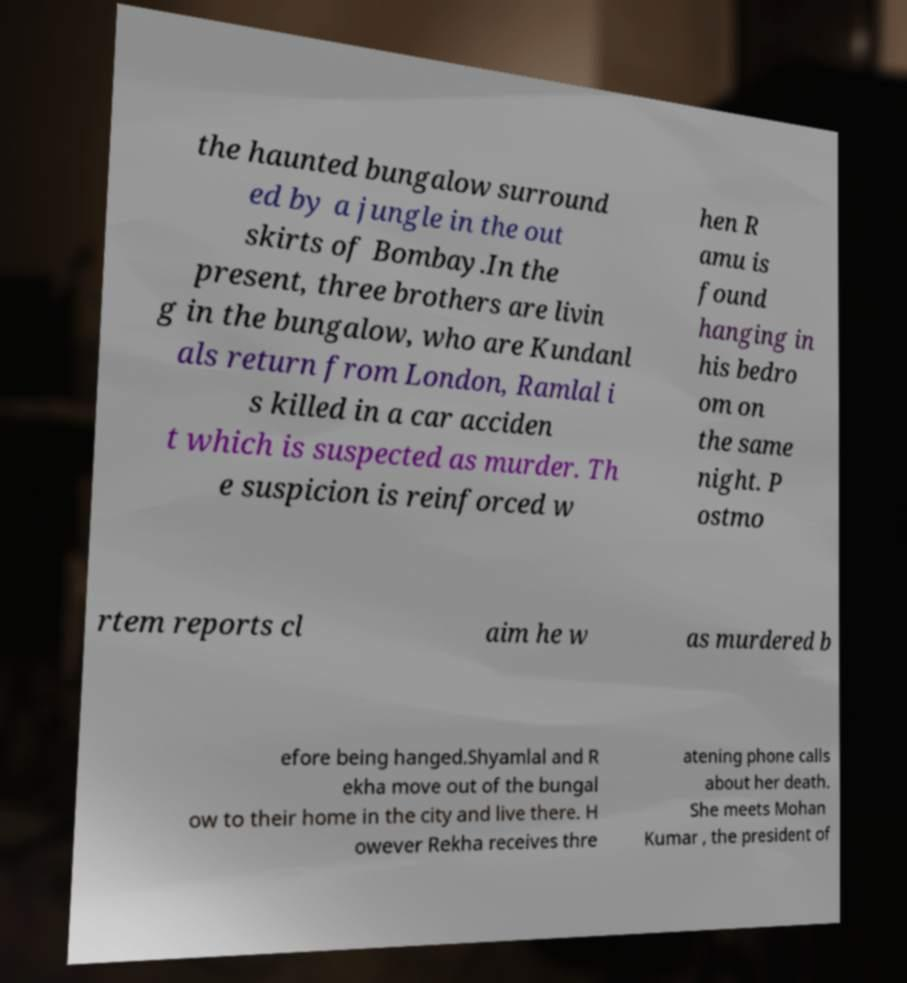What messages or text are displayed in this image? I need them in a readable, typed format. the haunted bungalow surround ed by a jungle in the out skirts of Bombay.In the present, three brothers are livin g in the bungalow, who are Kundanl als return from London, Ramlal i s killed in a car acciden t which is suspected as murder. Th e suspicion is reinforced w hen R amu is found hanging in his bedro om on the same night. P ostmo rtem reports cl aim he w as murdered b efore being hanged.Shyamlal and R ekha move out of the bungal ow to their home in the city and live there. H owever Rekha receives thre atening phone calls about her death. She meets Mohan Kumar , the president of 